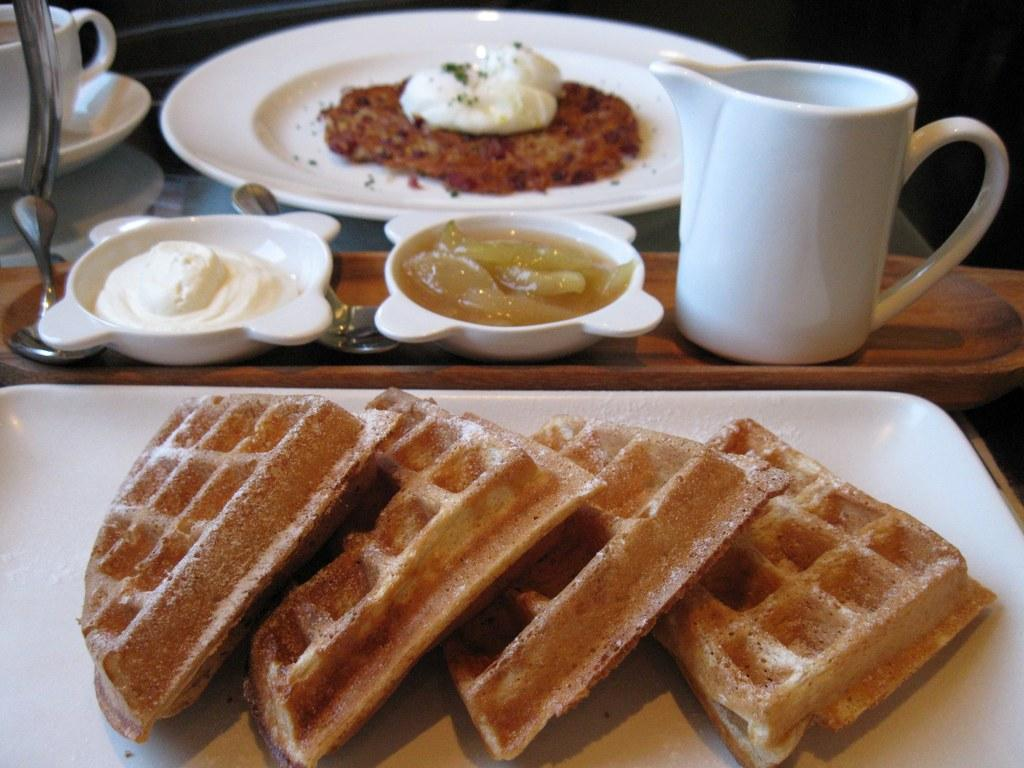What is located in the foreground of the image? There is a tray in the foreground of the image. What is on the tray? There are wafers on the tray. Can you describe any other food-related items in the image? Yes, there are bowls, a plate containing food items, a mug, spoons, a cup, and a saucer in the image. How many ants can be seen carrying the wafers in the image? There are no ants present in the image; it only shows wafers on a tray. What type of conversation are the horses having in the image? There are no horses present in the image, so it is not possible to determine what type of conversation they might be having. 